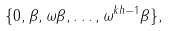<formula> <loc_0><loc_0><loc_500><loc_500>\{ 0 , \beta , \omega \beta , \dots , \omega ^ { k h - 1 } \beta \} ,</formula> 